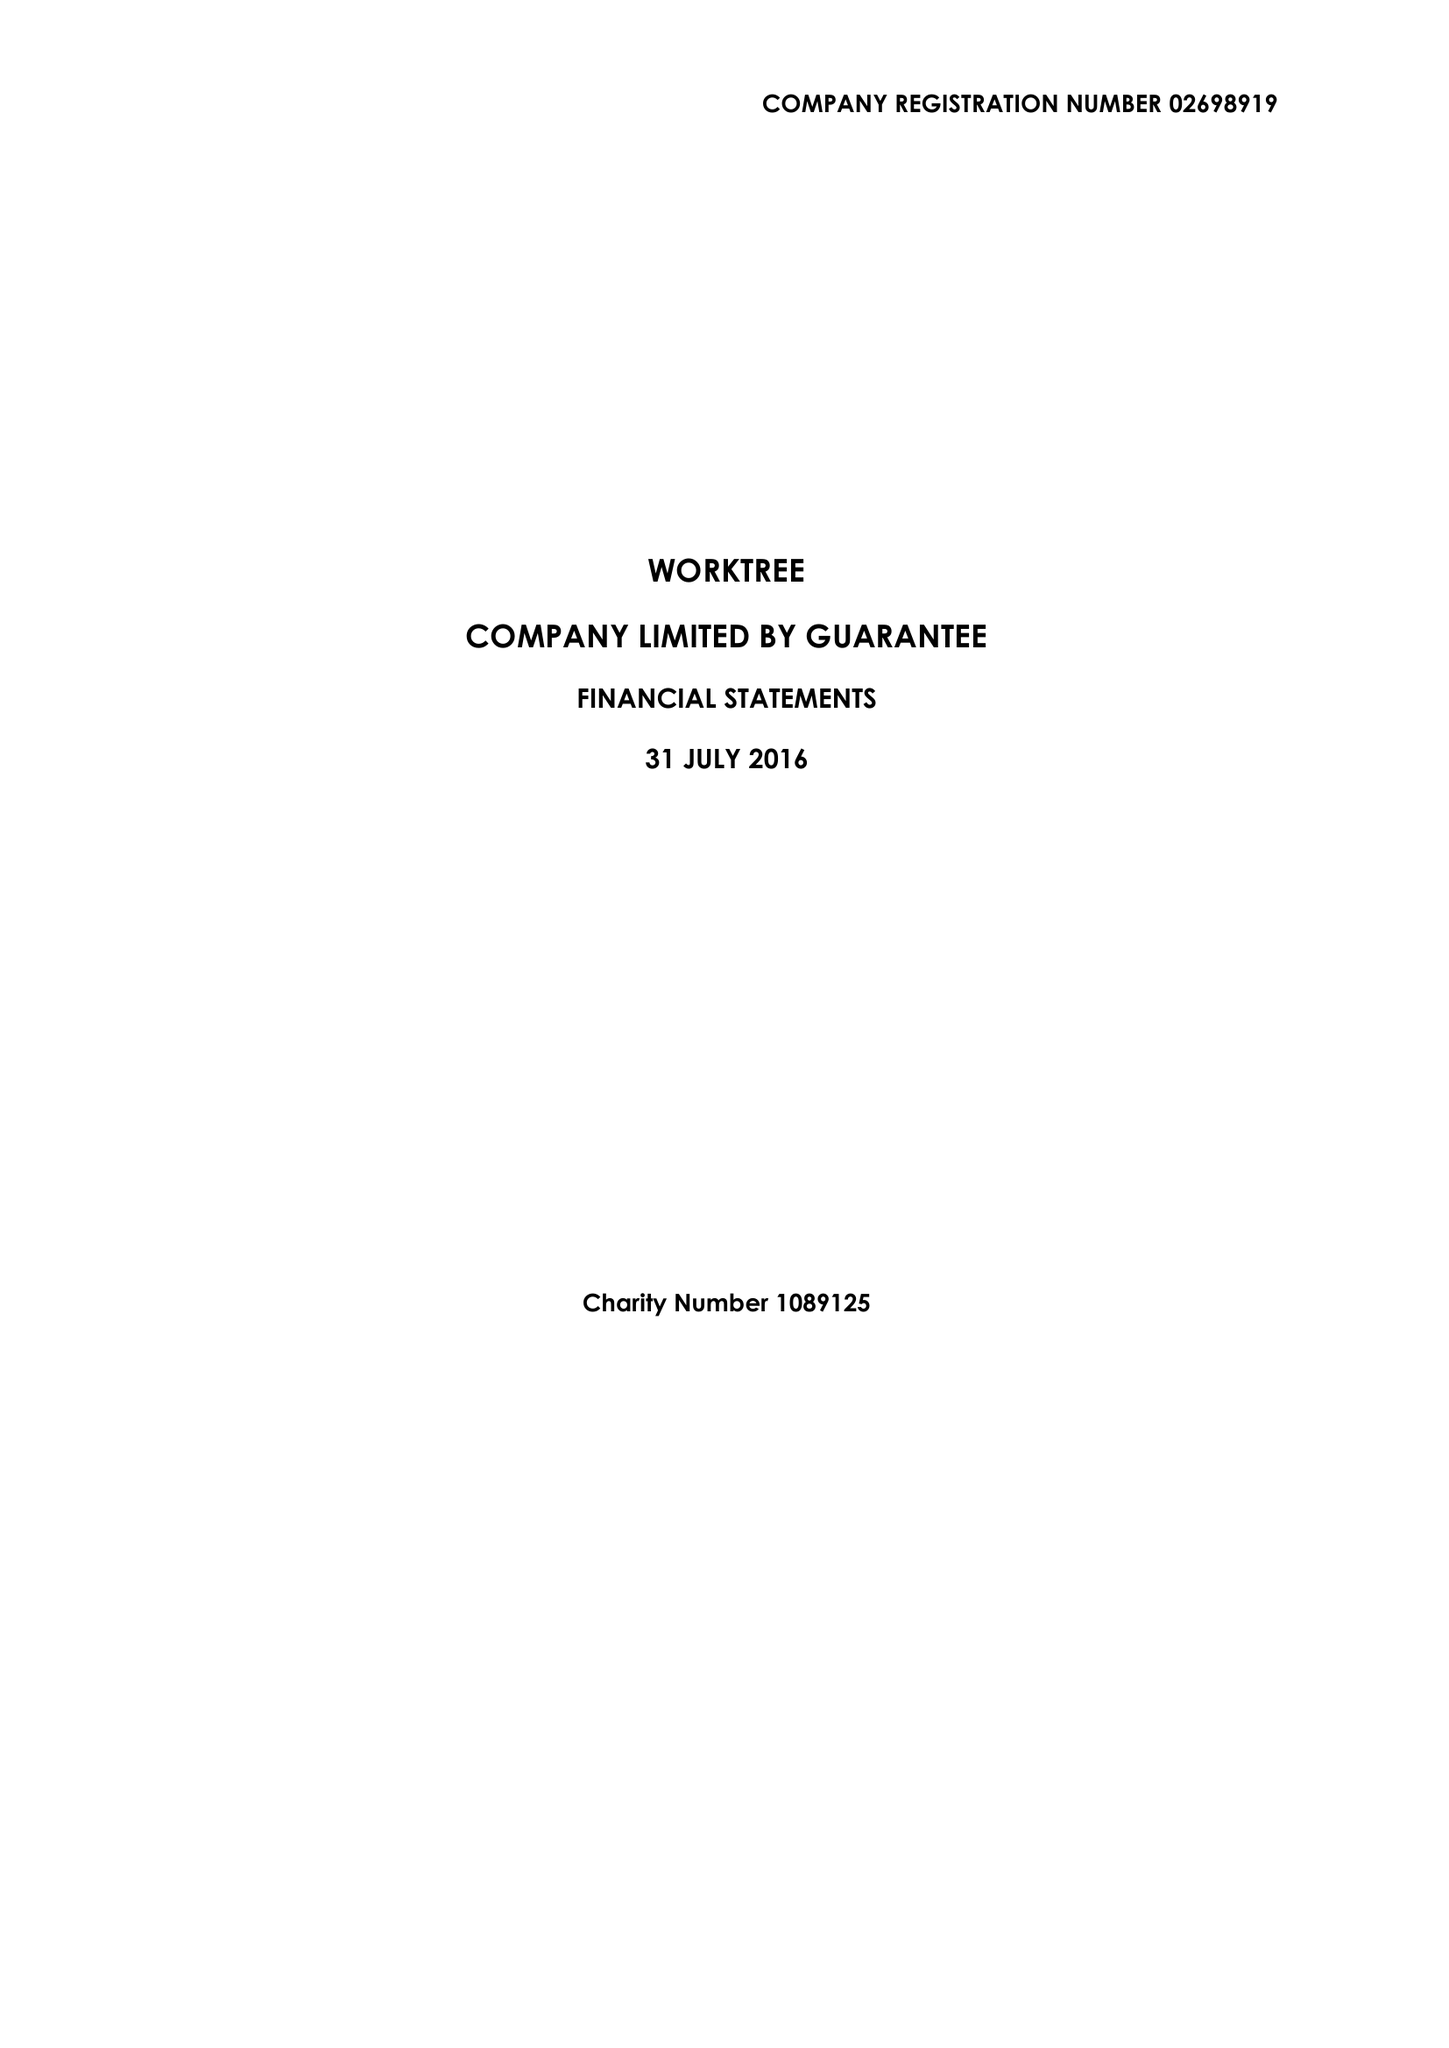What is the value for the charity_number?
Answer the question using a single word or phrase. 1089125 